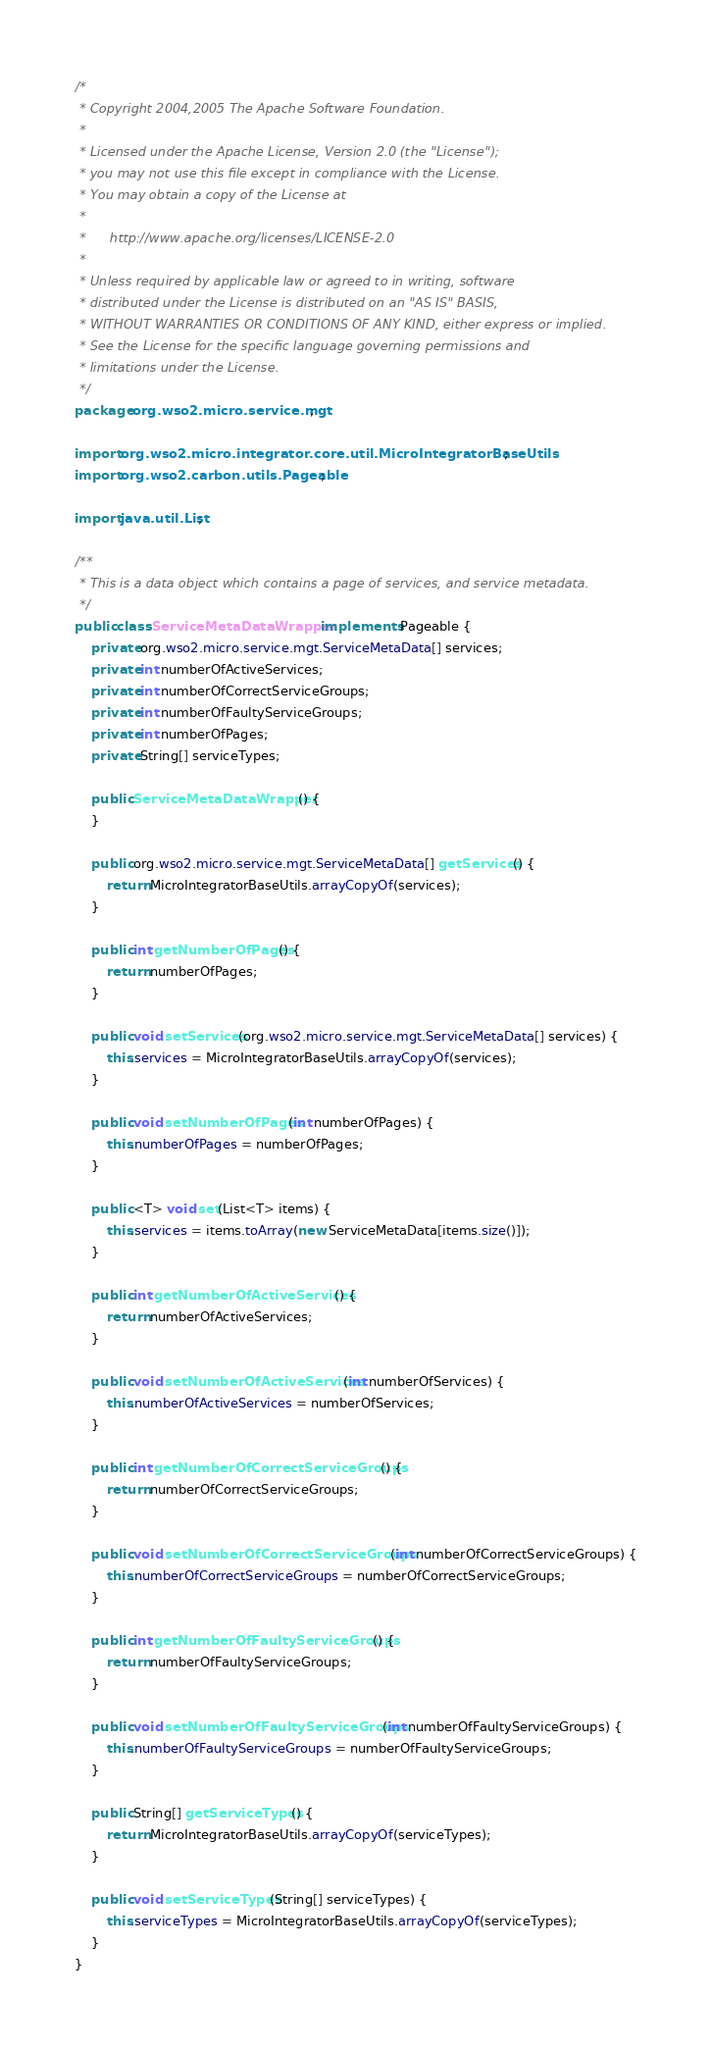<code> <loc_0><loc_0><loc_500><loc_500><_Java_>/*                                                                             
 * Copyright 2004,2005 The Apache Software Foundation.                         
 *                                                                             
 * Licensed under the Apache License, Version 2.0 (the "License");             
 * you may not use this file except in compliance with the License.            
 * You may obtain a copy of the License at                                     
 *                                                                             
 *      http://www.apache.org/licenses/LICENSE-2.0                             
 *                                                                             
 * Unless required by applicable law or agreed to in writing, software         
 * distributed under the License is distributed on an "AS IS" BASIS,           
 * WITHOUT WARRANTIES OR CONDITIONS OF ANY KIND, either express or implied.    
 * See the License for the specific language governing permissions and         
 * limitations under the License.                                              
 */
package org.wso2.micro.service.mgt;

import org.wso2.micro.integrator.core.util.MicroIntegratorBaseUtils;
import org.wso2.carbon.utils.Pageable;

import java.util.List;

/**
 * This is a data object which contains a page of services, and service metadata.
 */
public class ServiceMetaDataWrapper implements Pageable {
    private org.wso2.micro.service.mgt.ServiceMetaData[] services;
    private int numberOfActiveServices;
    private int numberOfCorrectServiceGroups;
    private int numberOfFaultyServiceGroups;
    private int numberOfPages;
    private String[] serviceTypes;

    public ServiceMetaDataWrapper() {
    }

    public org.wso2.micro.service.mgt.ServiceMetaData[] getServices() {
        return MicroIntegratorBaseUtils.arrayCopyOf(services);
    }

    public int getNumberOfPages() {
        return numberOfPages;
    }

    public void setServices(org.wso2.micro.service.mgt.ServiceMetaData[] services) {
        this.services = MicroIntegratorBaseUtils.arrayCopyOf(services);
    }

    public void setNumberOfPages(int numberOfPages) {
        this.numberOfPages = numberOfPages;
    }

    public <T> void set(List<T> items) {
        this.services = items.toArray(new ServiceMetaData[items.size()]);
    }

    public int getNumberOfActiveServices() {
        return numberOfActiveServices;
    }

    public void setNumberOfActiveServices(int numberOfServices) {
        this.numberOfActiveServices = numberOfServices;
    }

    public int getNumberOfCorrectServiceGroups() {
        return numberOfCorrectServiceGroups;
    }

    public void setNumberOfCorrectServiceGroups(int numberOfCorrectServiceGroups) {
        this.numberOfCorrectServiceGroups = numberOfCorrectServiceGroups;
    }

    public int getNumberOfFaultyServiceGroups() {
        return numberOfFaultyServiceGroups;
    }

    public void setNumberOfFaultyServiceGroups(int numberOfFaultyServiceGroups) {
        this.numberOfFaultyServiceGroups = numberOfFaultyServiceGroups;
    }

    public String[] getServiceTypes() {
        return MicroIntegratorBaseUtils.arrayCopyOf(serviceTypes);
    }

    public void setServiceTypes(String[] serviceTypes) {
        this.serviceTypes = MicroIntegratorBaseUtils.arrayCopyOf(serviceTypes);
    }
}
</code> 